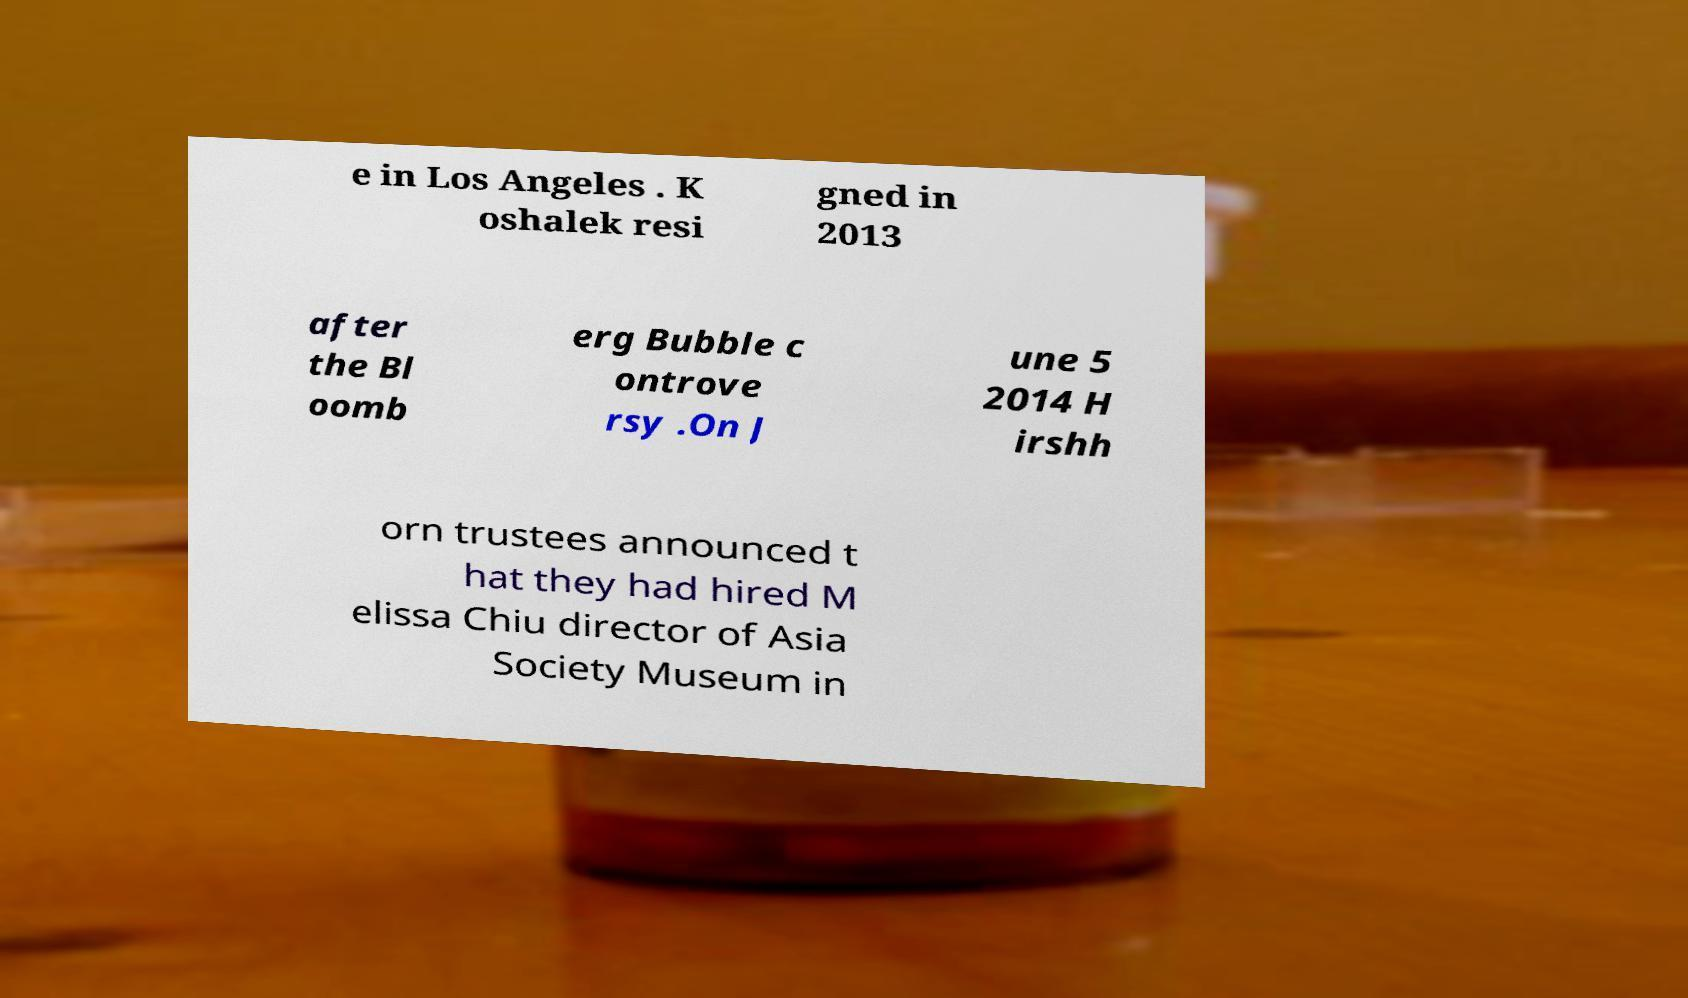There's text embedded in this image that I need extracted. Can you transcribe it verbatim? e in Los Angeles . K oshalek resi gned in 2013 after the Bl oomb erg Bubble c ontrove rsy .On J une 5 2014 H irshh orn trustees announced t hat they had hired M elissa Chiu director of Asia Society Museum in 